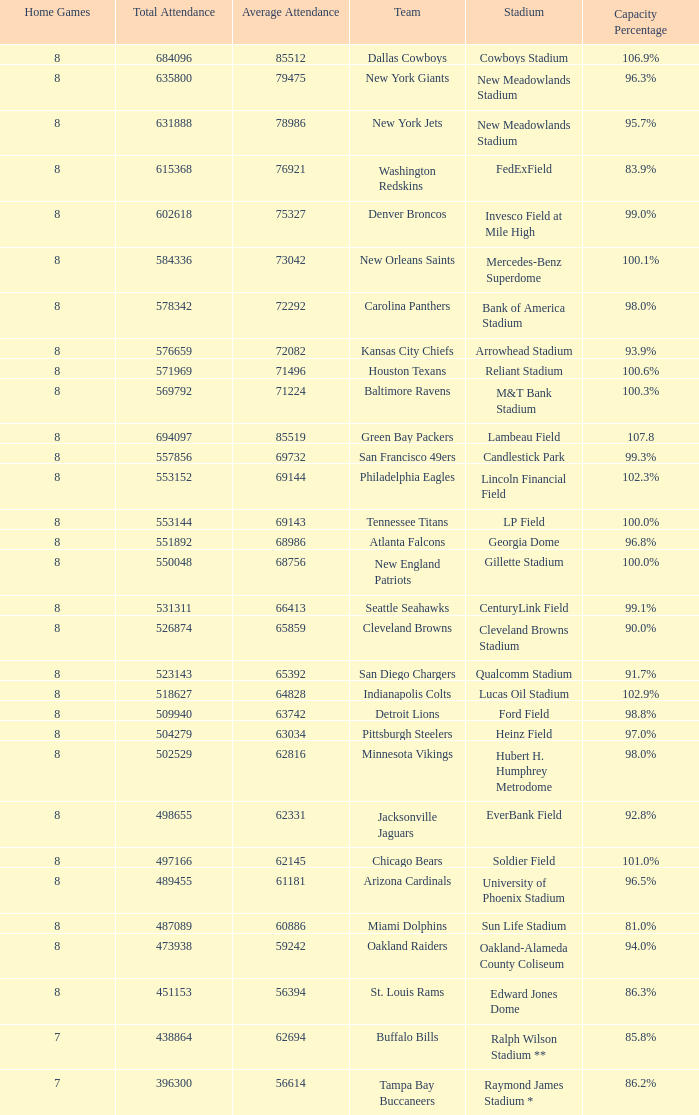What is the capacity percentage when the total attendance is 509940? 98.8%. 